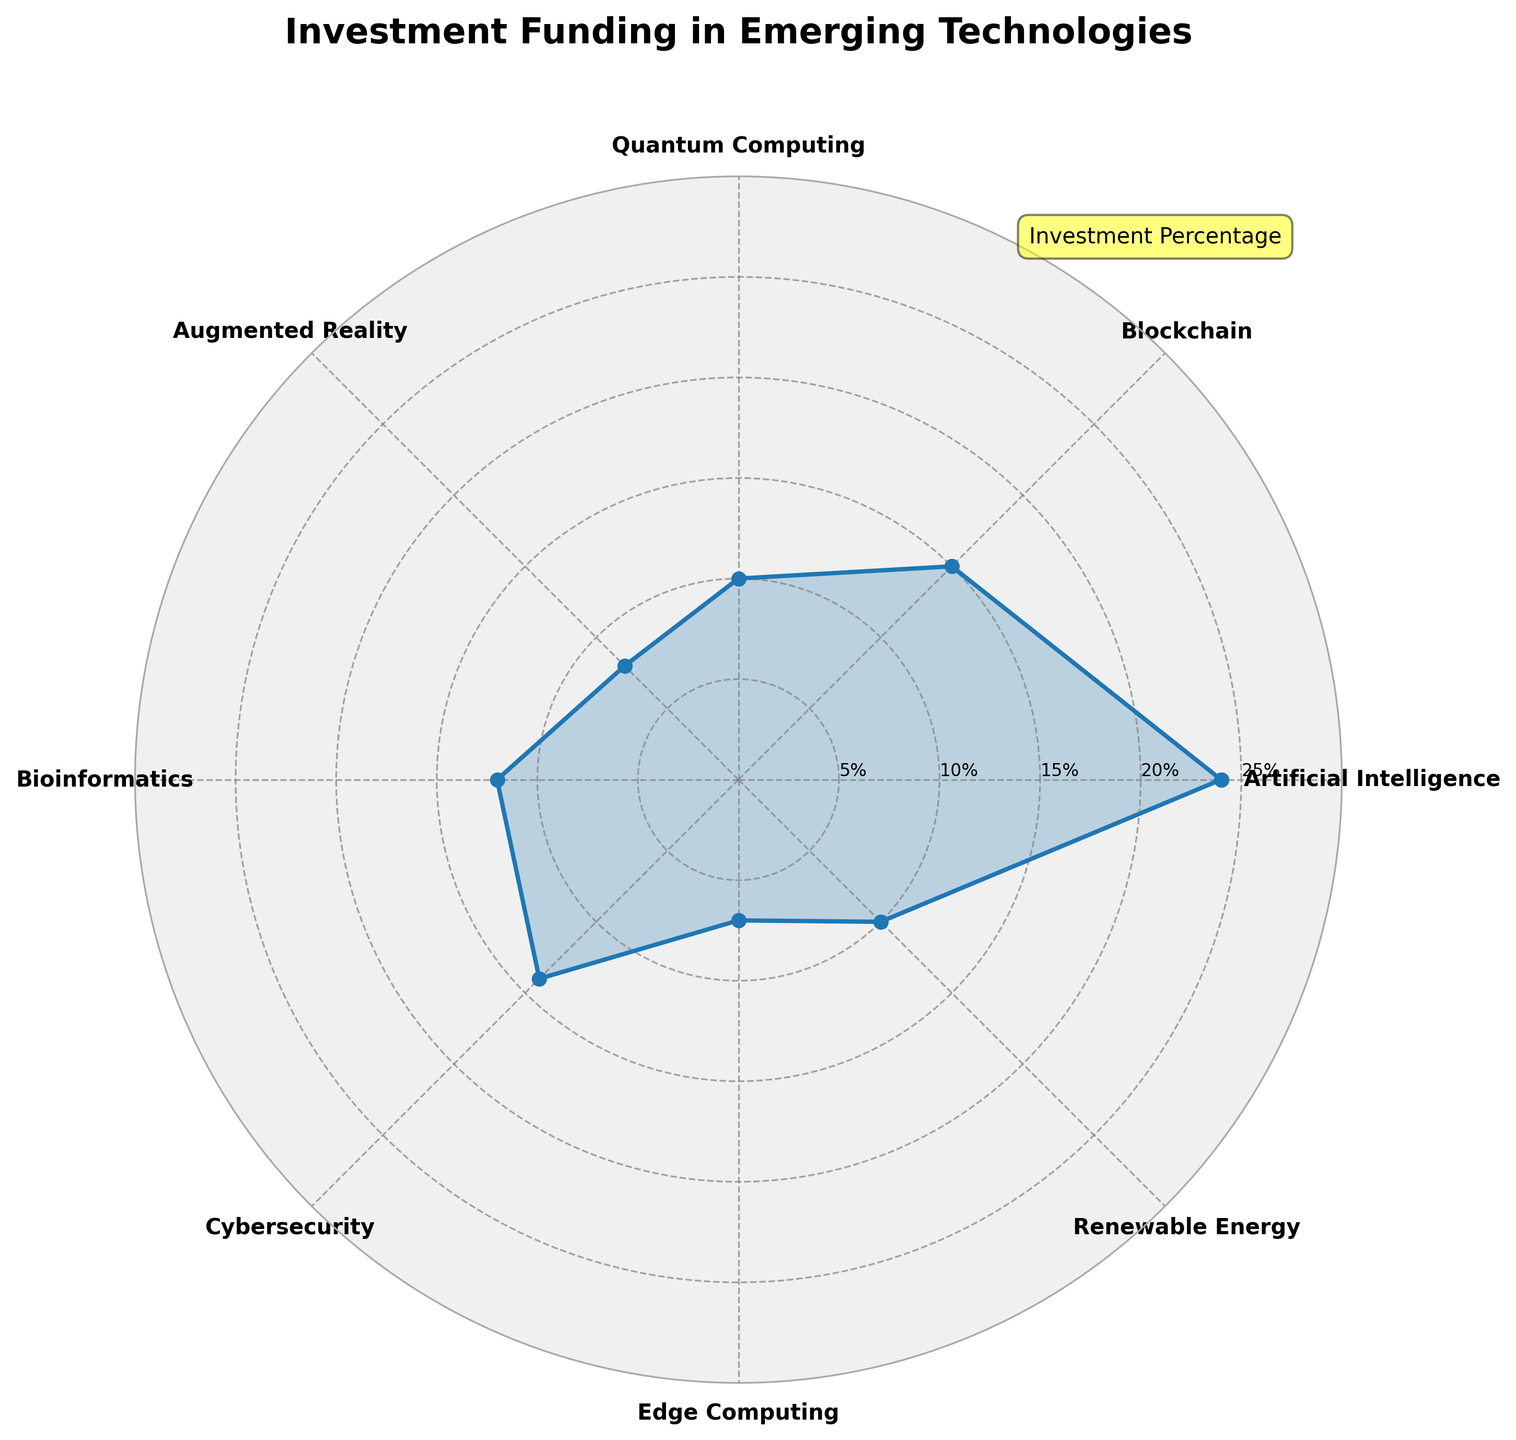What's the title of the figure? The title of the figure is the text displayed at the top of the chart. It reads: "Investment Funding in Emerging Technologies".
Answer: Investment Funding in Emerging Technologies How many categories of technologies are displayed in the chart? The chart has one label for each category around the polar area representing different technologies. Counting these labels, the chart shows eight categories.
Answer: Eight Which technology has the highest percentage of investment funding? The largest shaded area and data point on the chart reaches the highest radial value, which aligns with the label for "Artificial Intelligence".
Answer: Artificial Intelligence What's the combined investment percentage of Blockchain and Cybersecurity? Referring to the chart, the investment percentages are 15% for Blockchain and 14% for Cybersecurity. Adding these values, you get 15% + 14% = 29%.
Answer: 29% What percentage of investment does Edge Computing have compared to the total investment of Bioinformatics and Augmented Reality? Edge Computing has a 7% investment. Bioinformatics and Augmented Reality each have 12% and 8%, respectively. Summing these two: 12% + 8% = 20%. The ratio is calculated as (7/20) * 100, which is 35%.
Answer: 35% Which technology has a smaller percentage of investment, Quantum Computing or Renewable Energy? The radial length for Quantum Computing and Renewable Energy are compared. Both categories have equal lengths of 10%.
Answer: Both are equal What's the percentage difference between Artificial Intelligence and the technology with the least funding? Artificial Intelligence has the highest percentage at 24%, and the least funded is Edge Computing at 7%. The difference is calculated as 24% - 7%, which equals 17%.
Answer: 17% Arrange the technologies in descending order of their investment percentages. By analyzing the radial lengths, the order is: Artificial Intelligence (24%), Blockchain (15%), Cybersecurity (14%), Bioinformatics (12%), Quantum Computing (10%), Renewable Energy (10%), Augmented Reality (8%), Edge Computing (7%).
Answer: Artificial Intelligence, Blockchain, Cybersecurity, Bioinformatics, Quantum Computing, Renewable Energy, Augmented Reality, Edge Computing 